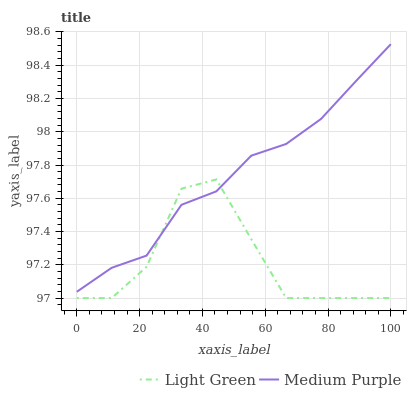Does Light Green have the minimum area under the curve?
Answer yes or no. Yes. Does Medium Purple have the maximum area under the curve?
Answer yes or no. Yes. Does Light Green have the maximum area under the curve?
Answer yes or no. No. Is Medium Purple the smoothest?
Answer yes or no. Yes. Is Light Green the roughest?
Answer yes or no. Yes. Is Light Green the smoothest?
Answer yes or no. No. Does Light Green have the lowest value?
Answer yes or no. Yes. Does Medium Purple have the highest value?
Answer yes or no. Yes. Does Light Green have the highest value?
Answer yes or no. No. Does Medium Purple intersect Light Green?
Answer yes or no. Yes. Is Medium Purple less than Light Green?
Answer yes or no. No. Is Medium Purple greater than Light Green?
Answer yes or no. No. 